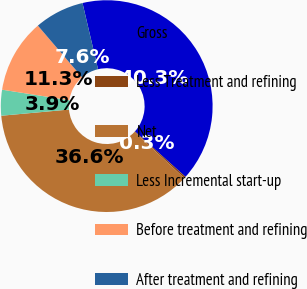Convert chart to OTSL. <chart><loc_0><loc_0><loc_500><loc_500><pie_chart><fcel>Gross<fcel>Less Treatment and refining<fcel>Net<fcel>Less Incremental start-up<fcel>Before treatment and refining<fcel>After treatment and refining<nl><fcel>40.32%<fcel>0.26%<fcel>36.65%<fcel>3.93%<fcel>11.26%<fcel>7.59%<nl></chart> 